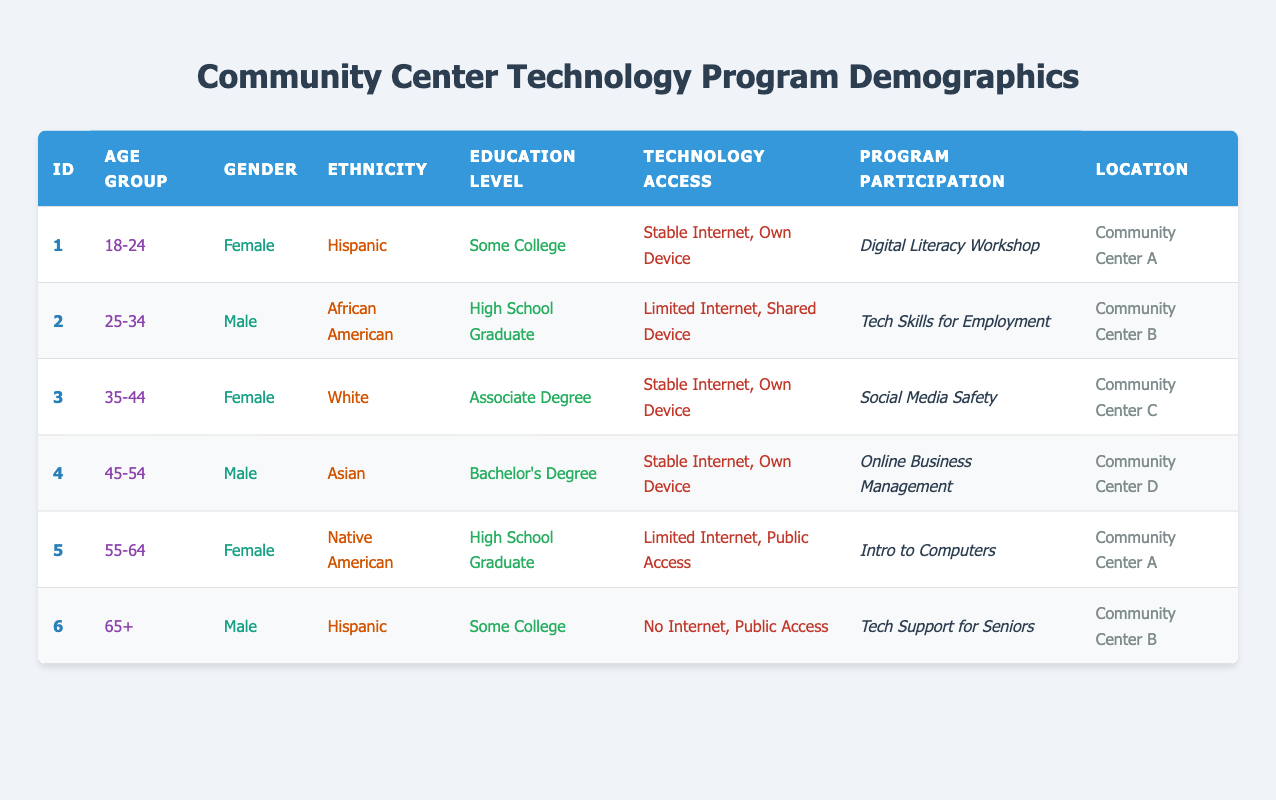What age group has the highest number of participants? Analyzing the age groups listed in the table, there are participants in the following groups: 18-24 (1 participant), 25-34 (1 participant), 35-44 (1 participant), 45-54 (1 participant), 55-64 (1 participant), and 65+ (1 participant). Each age group has exactly one participant, so no specific group has more than another.
Answer: No specific age group has the highest number Which community center has the most diverse gender representation? Reviewing the gender representation in each community center, Community Center A has 1 female, Community Center B has 1 male, Community Center C has 1 female, Community Center D has 1 male, and Community Center A includes another female. The total counts are: A (2 females), B (1 male), C (1 female), D (1 male). Therefore, Community Center A has the most gender diversity.
Answer: Community Center A Is there a participant with stable internet access and a bachelor's degree? By examining the table, the only participant with a bachelor's degree is from Community Center D (participant ID 4) who has stable internet access. Thus, the answer is yes.
Answer: Yes What is the average education level of the participants in terms of degrees? To calculate the average education level, we define the levels (High School Graduate = 1, Some College = 2, Associate Degree = 3, Bachelor's Degree = 4). Adding the scores: (2 + 1 + 3 + 4 + 1 + 2) = 13. There are 6 participants, so the average is 13/6 = 2.17. Rounding down, this corresponds to 'Some College'.
Answer: Some College Are all participants from different ethnic backgrounds? Reviewing the ethnic backgrounds of each participant, we have: Hispanic, African American, White, Asian, Native American, and Hispanic again. Since Hispanic appears twice, not all participants are from different ethnic backgrounds.
Answer: No How many participants have limited technology access and are 55 years or older? Participants over 55 years: (ID 5, ID 6). Checking their technology access, participant ID 5 (55-64 age group) has limited access, and participant ID 6 (65+) has no access. So, only participant ID 5 fits the criteria, giving us 1 participant.
Answer: 1 participant 